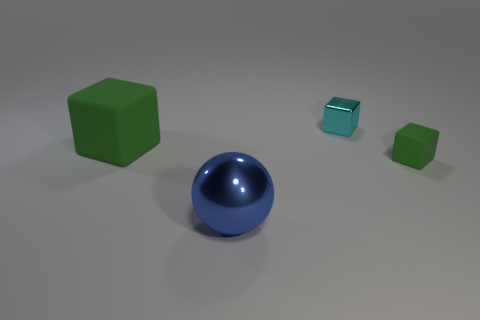Is the color of the tiny matte object the same as the big cube?
Offer a very short reply. Yes. What is the shape of the big metallic object?
Provide a short and direct response. Sphere. There is another tiny object that is the same shape as the small cyan thing; what is its material?
Provide a short and direct response. Rubber. How many yellow metallic cylinders are the same size as the metal ball?
Your answer should be very brief. 0. Is there a green rubber object to the right of the green thing left of the tiny green object?
Give a very brief answer. Yes. How many red things are either large rubber cubes or large spheres?
Provide a succinct answer. 0. The small metal block has what color?
Offer a terse response. Cyan. The cyan cube that is the same material as the ball is what size?
Make the answer very short. Small. What number of other tiny objects have the same shape as the small metallic object?
Make the answer very short. 1. What is the size of the green thing that is to the left of the green rubber cube on the right side of the blue metallic thing?
Ensure brevity in your answer.  Large. 